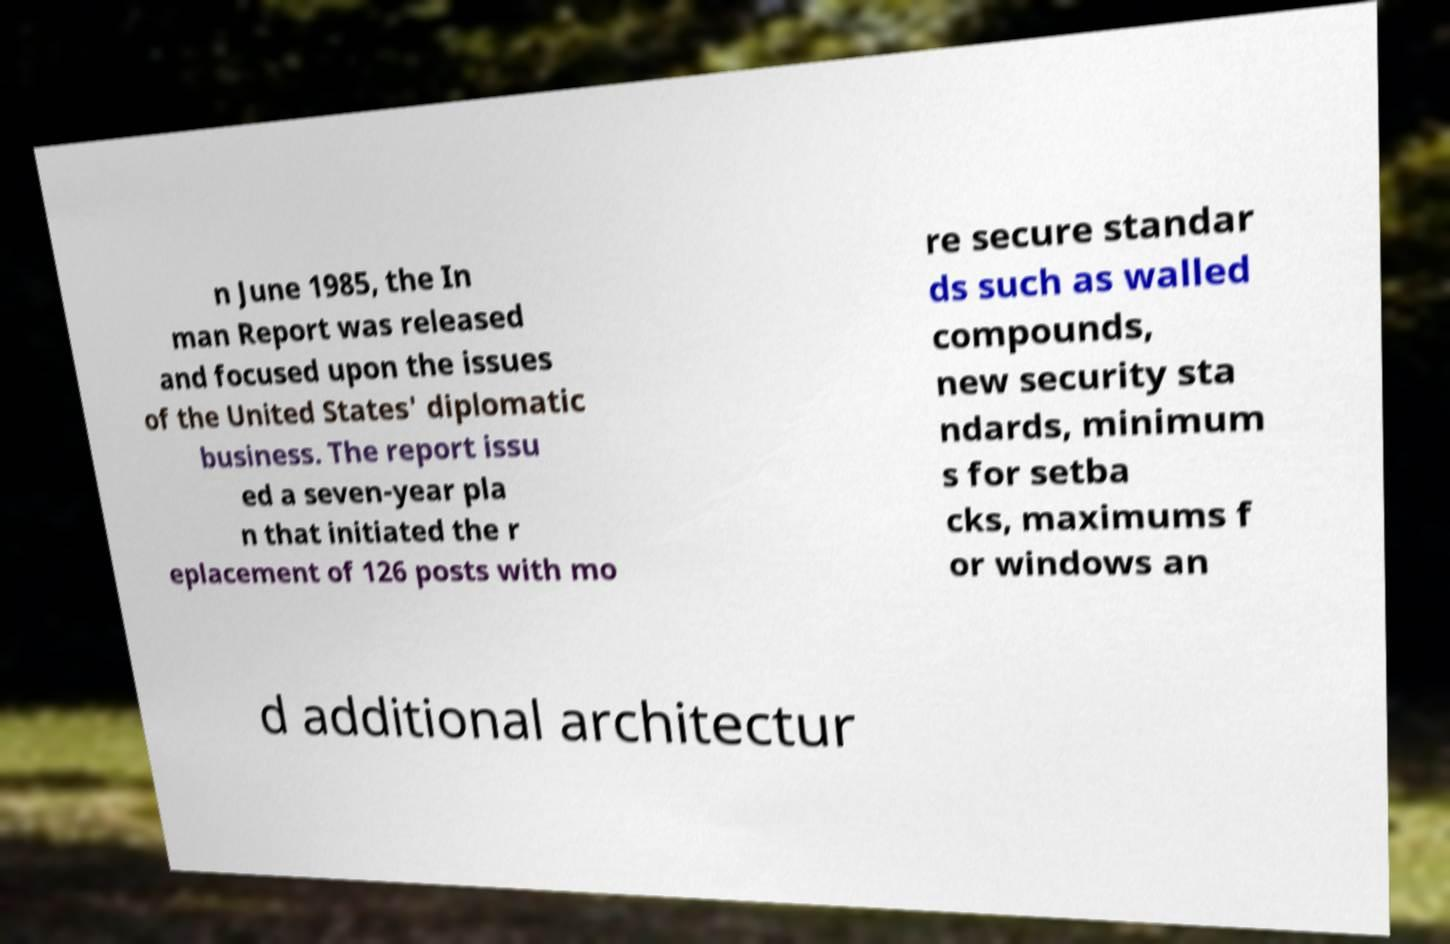For documentation purposes, I need the text within this image transcribed. Could you provide that? n June 1985, the In man Report was released and focused upon the issues of the United States' diplomatic business. The report issu ed a seven-year pla n that initiated the r eplacement of 126 posts with mo re secure standar ds such as walled compounds, new security sta ndards, minimum s for setba cks, maximums f or windows an d additional architectur 